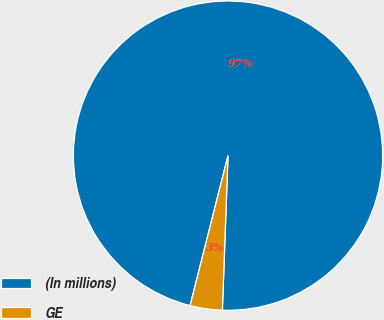Convert chart. <chart><loc_0><loc_0><loc_500><loc_500><pie_chart><fcel>(In millions)<fcel>GE<nl><fcel>96.64%<fcel>3.36%<nl></chart> 